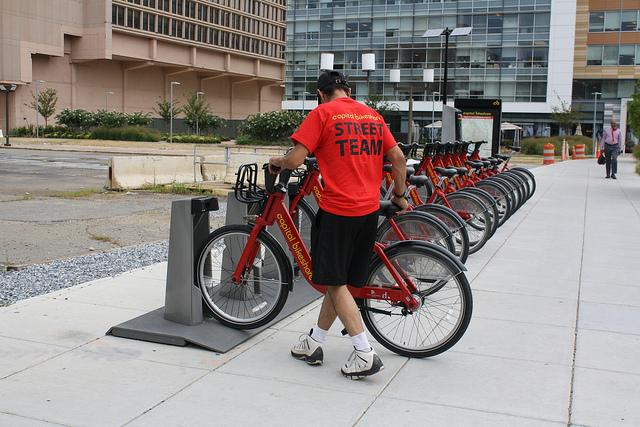What is the man standing next to the bikes most likely doing?

Choices:
A) travelling
B) exercising
C) training
D) working working 